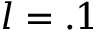<formula> <loc_0><loc_0><loc_500><loc_500>l = . 1</formula> 